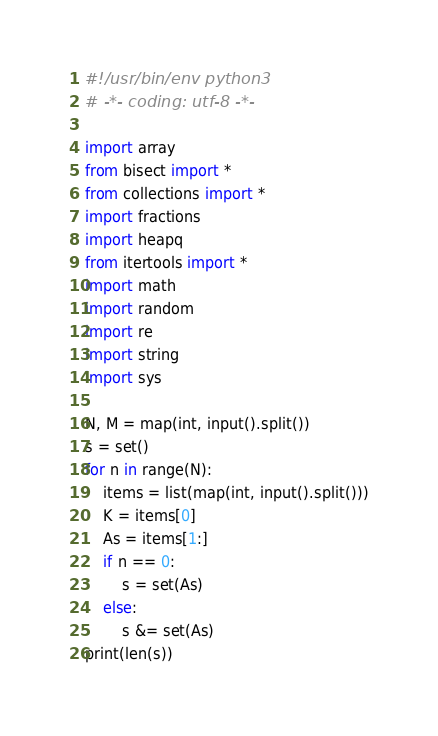Convert code to text. <code><loc_0><loc_0><loc_500><loc_500><_Python_>#!/usr/bin/env python3
# -*- coding: utf-8 -*-

import array
from bisect import *
from collections import *
import fractions
import heapq
from itertools import *
import math
import random
import re
import string
import sys

N, M = map(int, input().split())
s = set()
for n in range(N):
    items = list(map(int, input().split()))
    K = items[0]
    As = items[1:]
    if n == 0:
        s = set(As)
    else:
        s &= set(As)
print(len(s))
</code> 